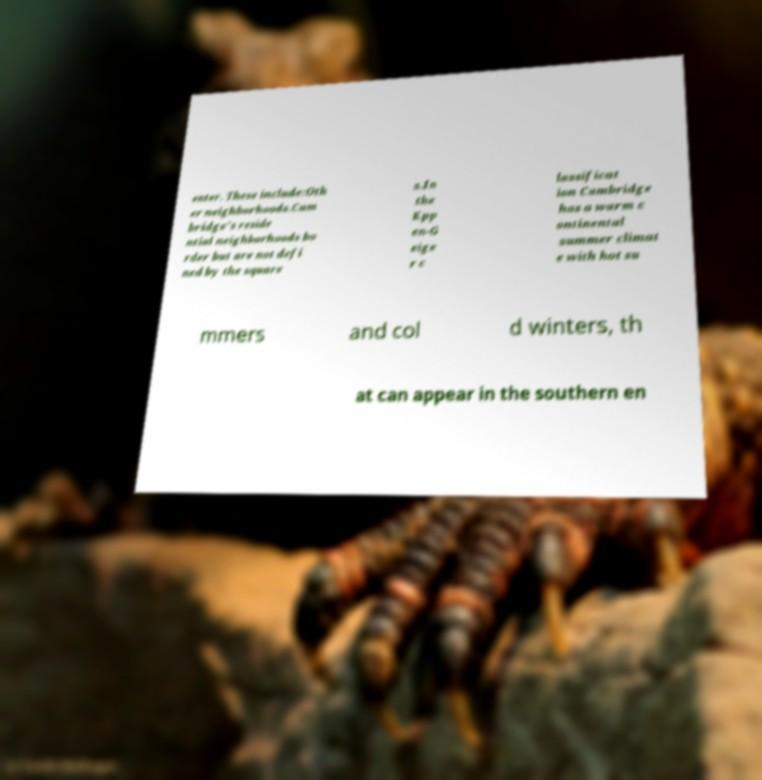Could you assist in decoding the text presented in this image and type it out clearly? enter. These include:Oth er neighborhoods.Cam bridge's reside ntial neighborhoods bo rder but are not defi ned by the square s.In the Kpp en-G eige r c lassificat ion Cambridge has a warm c ontinental summer climat e with hot su mmers and col d winters, th at can appear in the southern en 